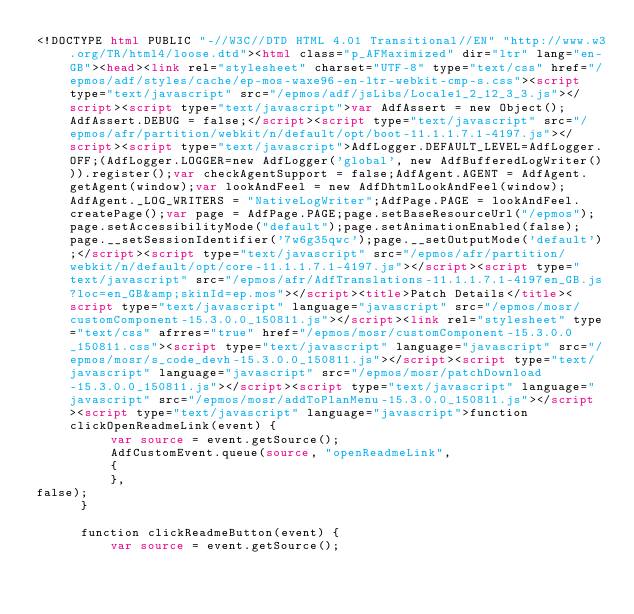Convert code to text. <code><loc_0><loc_0><loc_500><loc_500><_HTML_><!DOCTYPE html PUBLIC "-//W3C//DTD HTML 4.01 Transitional//EN" "http://www.w3.org/TR/html4/loose.dtd"><html class="p_AFMaximized" dir="ltr" lang="en-GB"><head><link rel="stylesheet" charset="UTF-8" type="text/css" href="/epmos/adf/styles/cache/ep-mos-waxe96-en-ltr-webkit-cmp-s.css"><script type="text/javascript" src="/epmos/adf/jsLibs/Locale1_2_12_3_3.js"></script><script type="text/javascript">var AdfAssert = new Object();AdfAssert.DEBUG = false;</script><script type="text/javascript" src="/epmos/afr/partition/webkit/n/default/opt/boot-11.1.1.7.1-4197.js"></script><script type="text/javascript">AdfLogger.DEFAULT_LEVEL=AdfLogger.OFF;(AdfLogger.LOGGER=new AdfLogger('global', new AdfBufferedLogWriter())).register();var checkAgentSupport = false;AdfAgent.AGENT = AdfAgent.getAgent(window);var lookAndFeel = new AdfDhtmlLookAndFeel(window);AdfAgent._LOG_WRITERS = "NativeLogWriter";AdfPage.PAGE = lookAndFeel.createPage();var page = AdfPage.PAGE;page.setBaseResourceUrl("/epmos");page.setAccessibilityMode("default");page.setAnimationEnabled(false);page.__setSessionIdentifier('7w6g35qwc');page.__setOutputMode('default');</script><script type="text/javascript" src="/epmos/afr/partition/webkit/n/default/opt/core-11.1.1.7.1-4197.js"></script><script type="text/javascript" src="/epmos/afr/AdfTranslations-11.1.1.7.1-4197en_GB.js?loc=en_GB&amp;skinId=ep.mos"></script><title>Patch Details</title><script type="text/javascript" language="javascript" src="/epmos/mosr/customComponent-15.3.0.0_150811.js"></script><link rel="stylesheet" type="text/css" afrres="true" href="/epmos/mosr/customComponent-15.3.0.0_150811.css"><script type="text/javascript" language="javascript" src="/epmos/mosr/s_code_devh-15.3.0.0_150811.js"></script><script type="text/javascript" language="javascript" src="/epmos/mosr/patchDownload-15.3.0.0_150811.js"></script><script type="text/javascript" language="javascript" src="/epmos/mosr/addToPlanMenu-15.3.0.0_150811.js"></script><script type="text/javascript" language="javascript">function clickOpenReadmeLink(event) {
          var source = event.getSource();
          AdfCustomEvent.queue(source, "openReadmeLink", 
          {
          },
false);
      }

      function clickReadmeButton(event) {
          var source = event.getSource();</code> 